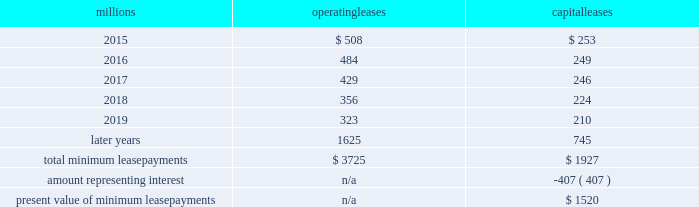Direct the activities of the vies and , therefore , do not control the ongoing activities that have a significant impact on the economic performance of the vies .
Additionally , we do not have the obligation to absorb losses of the vies or the right to receive benefits of the vies that could potentially be significant to the we are not considered to be the primary beneficiary and do not consolidate these vies because our actions and decisions do not have the most significant effect on the vie 2019s performance and our fixed-price purchase options are not considered to be potentially significant to the vies .
The future minimum lease payments associated with the vie leases totaled $ 3.0 billion as of december 31 , 2014 .
17 .
Leases we lease certain locomotives , freight cars , and other property .
The consolidated statements of financial position as of december 31 , 2014 and 2013 included $ 2454 million , net of $ 1210 million of accumulated depreciation , and $ 2486 million , net of $ 1092 million of accumulated depreciation , respectively , for properties held under capital leases .
A charge to income resulting from the depreciation for assets held under capital leases is included within depreciation expense in our consolidated statements of income .
Future minimum lease payments for operating and capital leases with initial or remaining non-cancelable lease terms in excess of one year as of december 31 , 2014 , were as follows : millions operating leases capital leases .
Approximately 95% ( 95 % ) of capital lease payments relate to locomotives .
Rent expense for operating leases with terms exceeding one month was $ 593 million in 2014 , $ 618 million in 2013 , and $ 631 million in 2012 .
When cash rental payments are not made on a straight-line basis , we recognize variable rental expense on a straight-line basis over the lease term .
Contingent rentals and sub-rentals are not significant .
18 .
Commitments and contingencies asserted and unasserted claims 2013 various claims and lawsuits are pending against us and certain of our subsidiaries .
We cannot fully determine the effect of all asserted and unasserted claims on our consolidated results of operations , financial condition , or liquidity ; however , to the extent possible , where asserted and unasserted claims are considered probable and where such claims can be reasonably estimated , we have recorded a liability .
We do not expect that any known lawsuits , claims , environmental costs , commitments , contingent liabilities , or guarantees will have a material adverse effect on our consolidated results of operations , financial condition , or liquidity after taking into account liabilities and insurance recoveries previously recorded for these matters .
Personal injury 2013 the cost of personal injuries to employees and others related to our activities is charged to expense based on estimates of the ultimate cost and number of incidents each year .
We use an actuarial analysis to measure the expense and liability , including unasserted claims .
The federal employers 2019 liability act ( fela ) governs compensation for work-related accidents .
Under fela , damages are assessed based on a finding of fault through litigation or out-of-court settlements .
We offer a comprehensive variety of services and rehabilitation programs for employees who are injured at work .
Our personal injury liability is not discounted to present value due to the uncertainty surrounding the timing of future payments .
Approximately 93% ( 93 % ) of the recorded liability is related to asserted claims and approximately 7% ( 7 % ) is related to unasserted claims at december 31 , 2014 .
Because of the uncertainty .
What percentage of total minimum lease payments are capital leases? 
Computations: (1927 / (3725 + 1927))
Answer: 0.34094. 